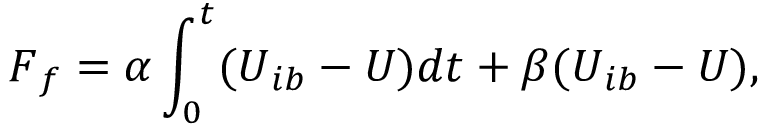Convert formula to latex. <formula><loc_0><loc_0><loc_500><loc_500>F _ { f } = \alpha \int _ { 0 } ^ { t } ( U _ { i b } - U ) d t + \beta ( U _ { i b } - U ) ,</formula> 